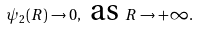Convert formula to latex. <formula><loc_0><loc_0><loc_500><loc_500>\psi _ { 2 } ( R ) \to 0 , \text { as } R \to + \infty .</formula> 